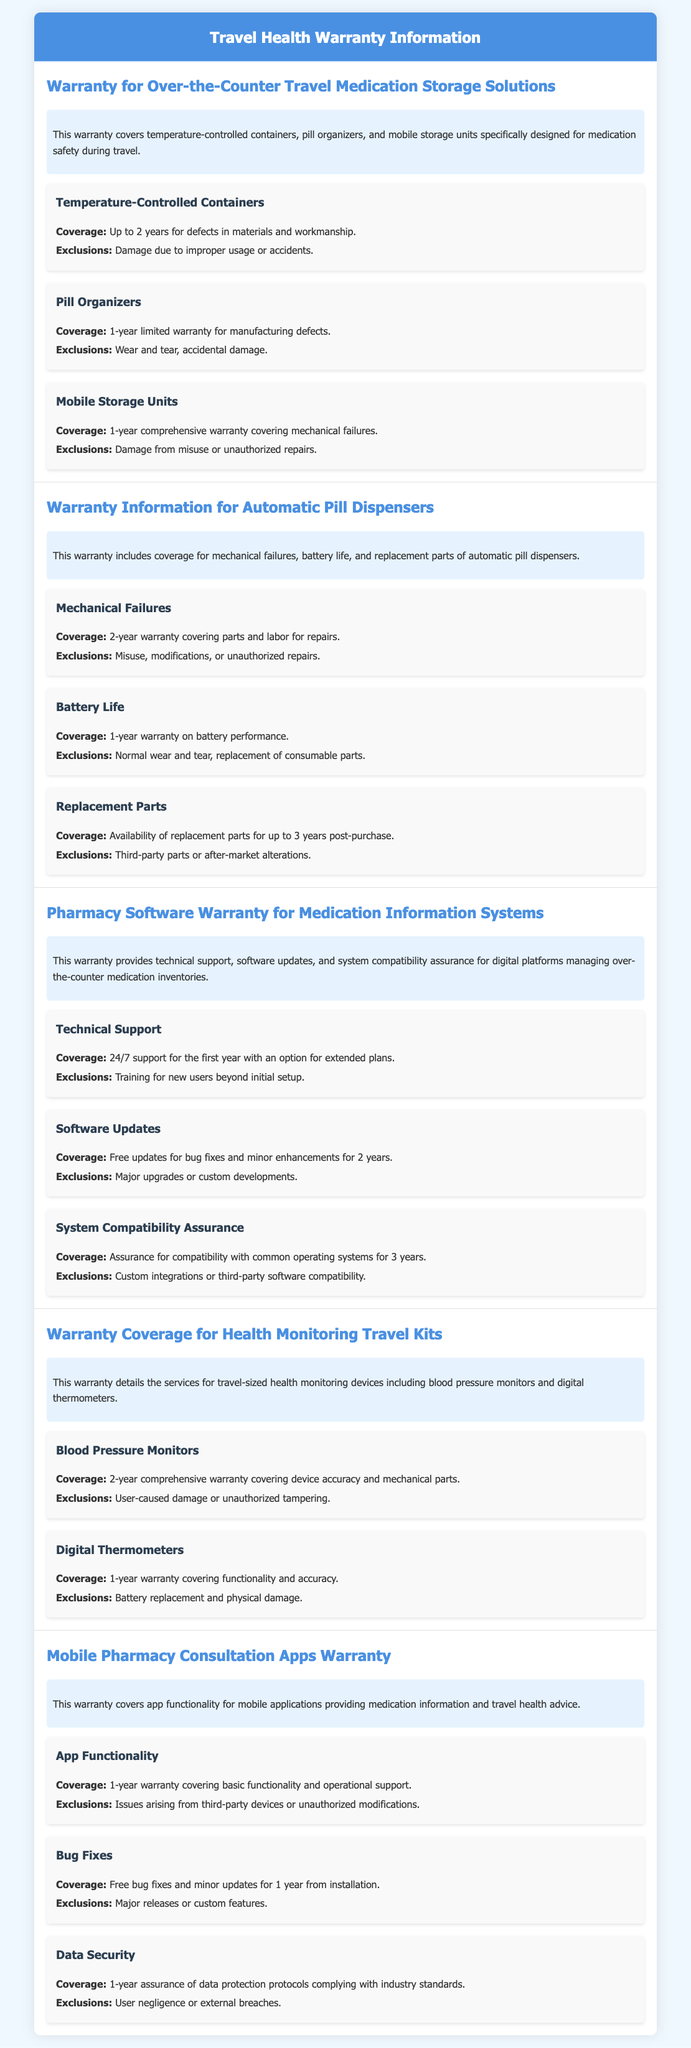What is the warranty coverage duration for temperature-controlled containers? The warranty covers temperature-controlled containers for up to 2 years for defects in materials and workmanship.
Answer: 2 years What are the exclusions for the warranty of pill organizers? The exclusions for pill organizers include wear and tear and accidental damage.
Answer: Wear and tear, accidental damage How long is the warranty for battery performance in automatic pill dispensers? The warranty for battery performance is 1 year.
Answer: 1 year What kind of technical support is provided during the first year for pharmacy software? The warranty provides 24/7 support for the first year with an option for extended plans.
Answer: 24/7 support What is the coverage duration for free bug fixes and minor updates for mobile pharmacy consultation apps? The coverage duration for free bug fixes and minor updates is 1 year from installation.
Answer: 1 year What type of damage is excluded from the warranty for blood pressure monitors? User-caused damage or unauthorized tampering are excluded from the warranty for blood pressure monitors.
Answer: User-caused damage, unauthorized tampering What does the warranty for digital thermometers cover? The warranty covers functionality and accuracy for digital thermometers.
Answer: Functionality and accuracy What is included in the warranty for mobile storage units? The warranty for mobile storage units includes a 1-year comprehensive warranty covering mechanical failures.
Answer: 1-year comprehensive warranty How long does the warranty assure compatibility for pharmacy software with common operating systems? The warranty assures compatibility for 3 years.
Answer: 3 years 